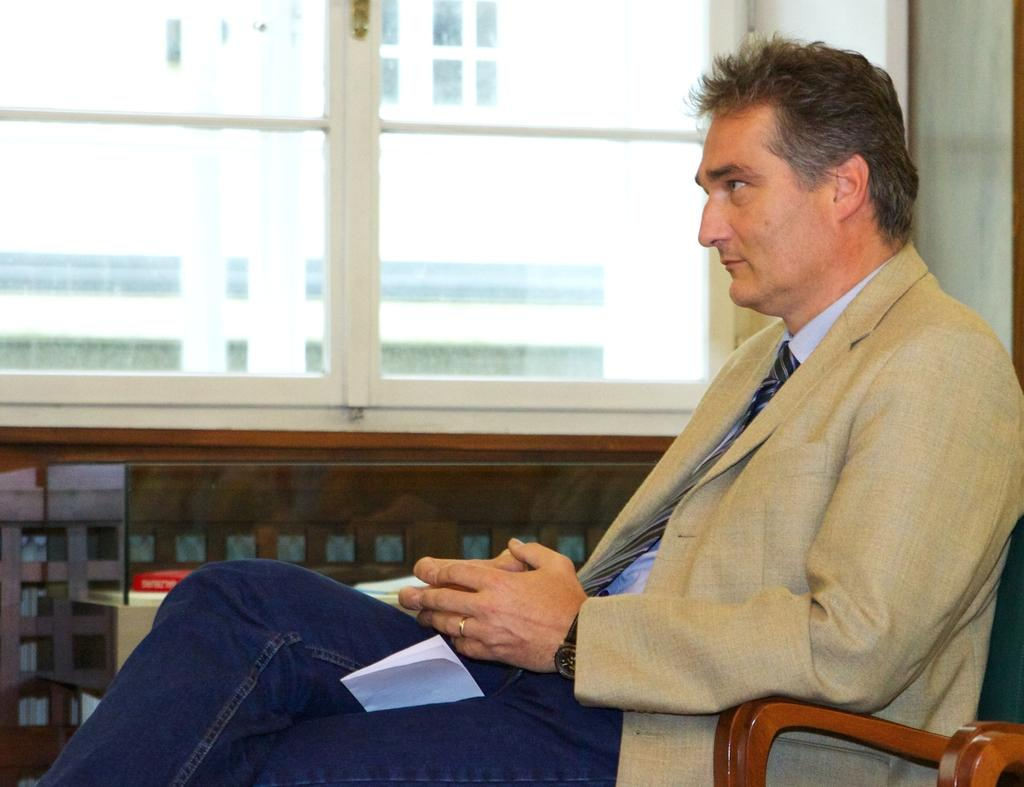What is the person in the image doing? The person is sitting on a chair in the image. What is the person holding in the image? The person is holding a paper with his legs. What can be seen through the window in the image? Unfortunately, the facts provided do not mention anything about the window or what can be seen through it. What type of lip balm is the person using in the image? There is no lip balm present in the image. What is the person's answer to the question on the paper? There is no indication in the image that the person is answering a question on the paper. 